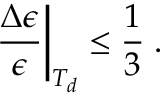Convert formula to latex. <formula><loc_0><loc_0><loc_500><loc_500>\frac { \Delta \epsilon } { \epsilon } \right | _ { T _ { d } } \leq \frac { 1 } { 3 } \, .</formula> 